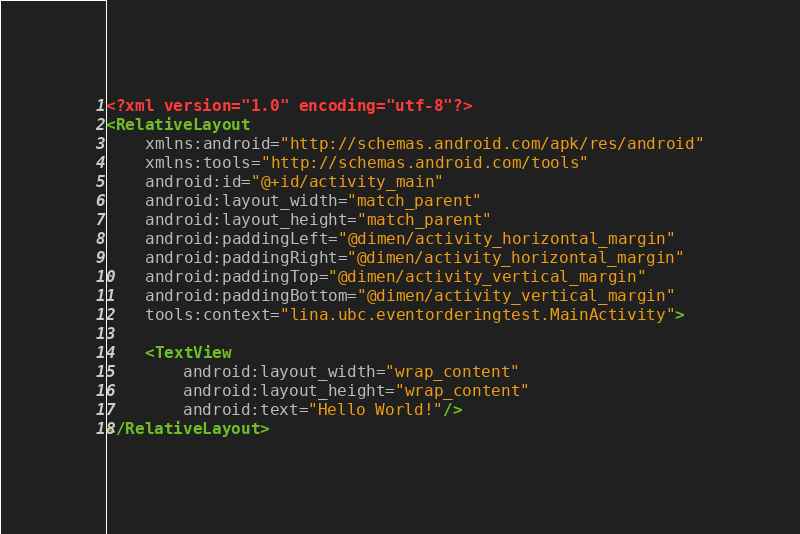<code> <loc_0><loc_0><loc_500><loc_500><_XML_><?xml version="1.0" encoding="utf-8"?>
<RelativeLayout
    xmlns:android="http://schemas.android.com/apk/res/android"
    xmlns:tools="http://schemas.android.com/tools"
    android:id="@+id/activity_main"
    android:layout_width="match_parent"
    android:layout_height="match_parent"
    android:paddingLeft="@dimen/activity_horizontal_margin"
    android:paddingRight="@dimen/activity_horizontal_margin"
    android:paddingTop="@dimen/activity_vertical_margin"
    android:paddingBottom="@dimen/activity_vertical_margin"
    tools:context="lina.ubc.eventorderingtest.MainActivity">

    <TextView
        android:layout_width="wrap_content"
        android:layout_height="wrap_content"
        android:text="Hello World!"/>
</RelativeLayout>
</code> 